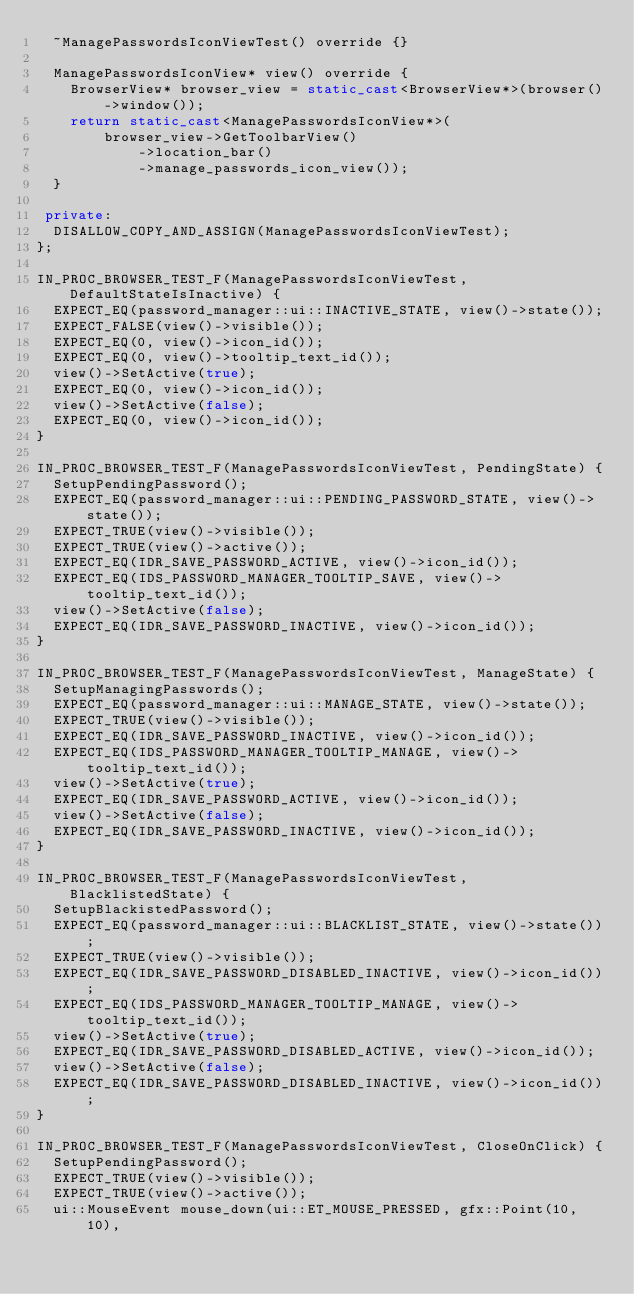<code> <loc_0><loc_0><loc_500><loc_500><_C++_>  ~ManagePasswordsIconViewTest() override {}

  ManagePasswordsIconView* view() override {
    BrowserView* browser_view = static_cast<BrowserView*>(browser()->window());
    return static_cast<ManagePasswordsIconView*>(
        browser_view->GetToolbarView()
            ->location_bar()
            ->manage_passwords_icon_view());
  }

 private:
  DISALLOW_COPY_AND_ASSIGN(ManagePasswordsIconViewTest);
};

IN_PROC_BROWSER_TEST_F(ManagePasswordsIconViewTest, DefaultStateIsInactive) {
  EXPECT_EQ(password_manager::ui::INACTIVE_STATE, view()->state());
  EXPECT_FALSE(view()->visible());
  EXPECT_EQ(0, view()->icon_id());
  EXPECT_EQ(0, view()->tooltip_text_id());
  view()->SetActive(true);
  EXPECT_EQ(0, view()->icon_id());
  view()->SetActive(false);
  EXPECT_EQ(0, view()->icon_id());
}

IN_PROC_BROWSER_TEST_F(ManagePasswordsIconViewTest, PendingState) {
  SetupPendingPassword();
  EXPECT_EQ(password_manager::ui::PENDING_PASSWORD_STATE, view()->state());
  EXPECT_TRUE(view()->visible());
  EXPECT_TRUE(view()->active());
  EXPECT_EQ(IDR_SAVE_PASSWORD_ACTIVE, view()->icon_id());
  EXPECT_EQ(IDS_PASSWORD_MANAGER_TOOLTIP_SAVE, view()->tooltip_text_id());
  view()->SetActive(false);
  EXPECT_EQ(IDR_SAVE_PASSWORD_INACTIVE, view()->icon_id());
}

IN_PROC_BROWSER_TEST_F(ManagePasswordsIconViewTest, ManageState) {
  SetupManagingPasswords();
  EXPECT_EQ(password_manager::ui::MANAGE_STATE, view()->state());
  EXPECT_TRUE(view()->visible());
  EXPECT_EQ(IDR_SAVE_PASSWORD_INACTIVE, view()->icon_id());
  EXPECT_EQ(IDS_PASSWORD_MANAGER_TOOLTIP_MANAGE, view()->tooltip_text_id());
  view()->SetActive(true);
  EXPECT_EQ(IDR_SAVE_PASSWORD_ACTIVE, view()->icon_id());
  view()->SetActive(false);
  EXPECT_EQ(IDR_SAVE_PASSWORD_INACTIVE, view()->icon_id());
}

IN_PROC_BROWSER_TEST_F(ManagePasswordsIconViewTest, BlacklistedState) {
  SetupBlackistedPassword();
  EXPECT_EQ(password_manager::ui::BLACKLIST_STATE, view()->state());
  EXPECT_TRUE(view()->visible());
  EXPECT_EQ(IDR_SAVE_PASSWORD_DISABLED_INACTIVE, view()->icon_id());
  EXPECT_EQ(IDS_PASSWORD_MANAGER_TOOLTIP_MANAGE, view()->tooltip_text_id());
  view()->SetActive(true);
  EXPECT_EQ(IDR_SAVE_PASSWORD_DISABLED_ACTIVE, view()->icon_id());
  view()->SetActive(false);
  EXPECT_EQ(IDR_SAVE_PASSWORD_DISABLED_INACTIVE, view()->icon_id());
}

IN_PROC_BROWSER_TEST_F(ManagePasswordsIconViewTest, CloseOnClick) {
  SetupPendingPassword();
  EXPECT_TRUE(view()->visible());
  EXPECT_TRUE(view()->active());
  ui::MouseEvent mouse_down(ui::ET_MOUSE_PRESSED, gfx::Point(10, 10),</code> 